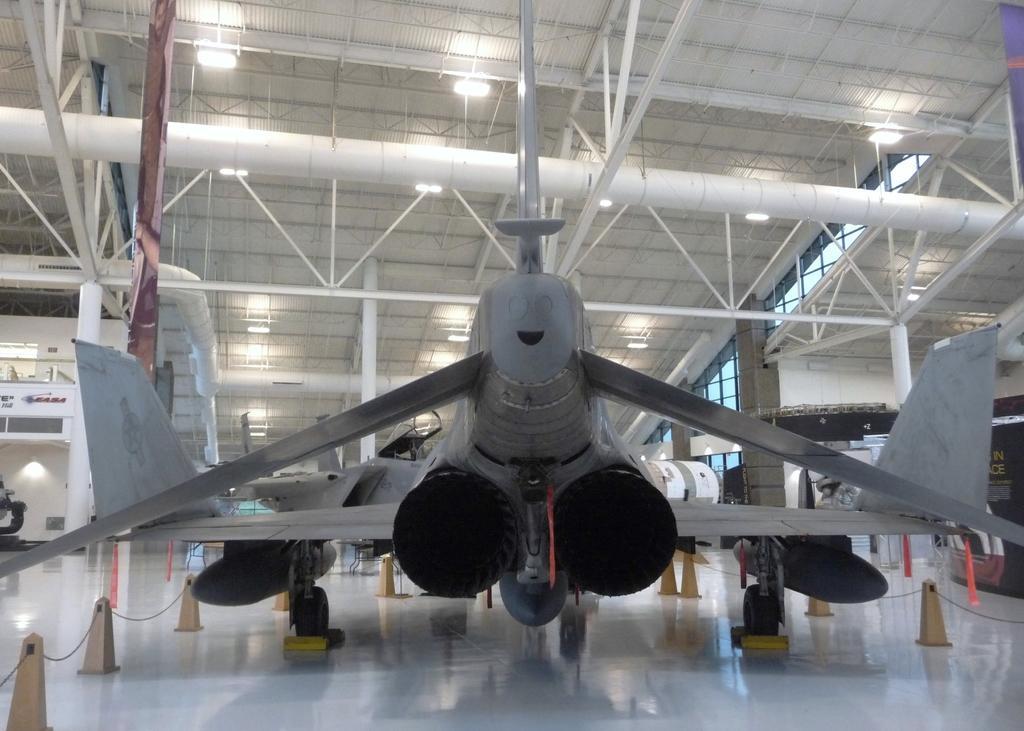In one or two sentences, can you explain what this image depicts? In the image on the floor there is a flight. Around the fight there is a fencing. At the top of the image there is a ceiling with lights, rods and pipes. In the background there are pillars. 